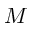<formula> <loc_0><loc_0><loc_500><loc_500>M</formula> 